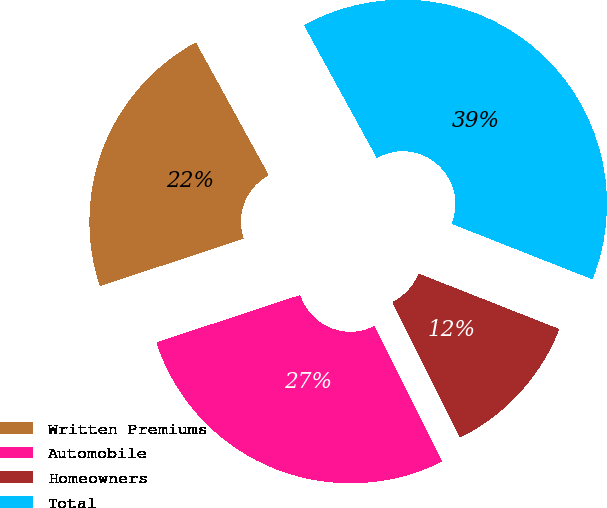Convert chart. <chart><loc_0><loc_0><loc_500><loc_500><pie_chart><fcel>Written Premiums<fcel>Automobile<fcel>Homeowners<fcel>Total<nl><fcel>22.07%<fcel>27.32%<fcel>11.64%<fcel>38.96%<nl></chart> 